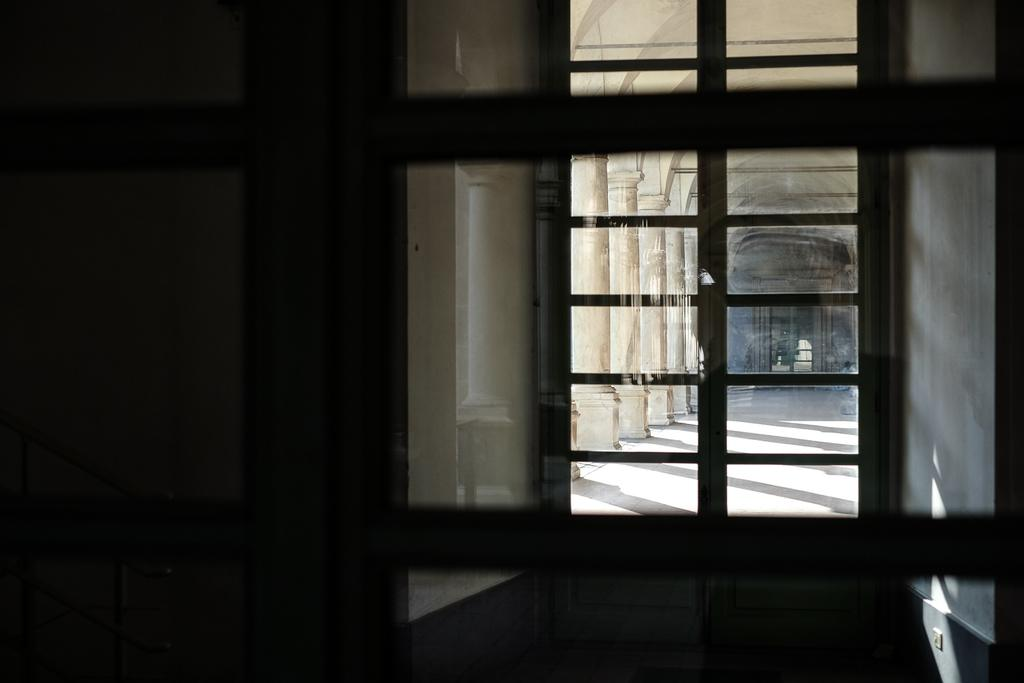What is the main subject of the image? The main subject of the image is a view of a building. How is the view of the building being observed? The view is seen through a glass door. What is the weight of the building in the image? The weight of the building cannot be determined from the image alone. What time of day is depicted in the image? The time of day is not specified in the image. 